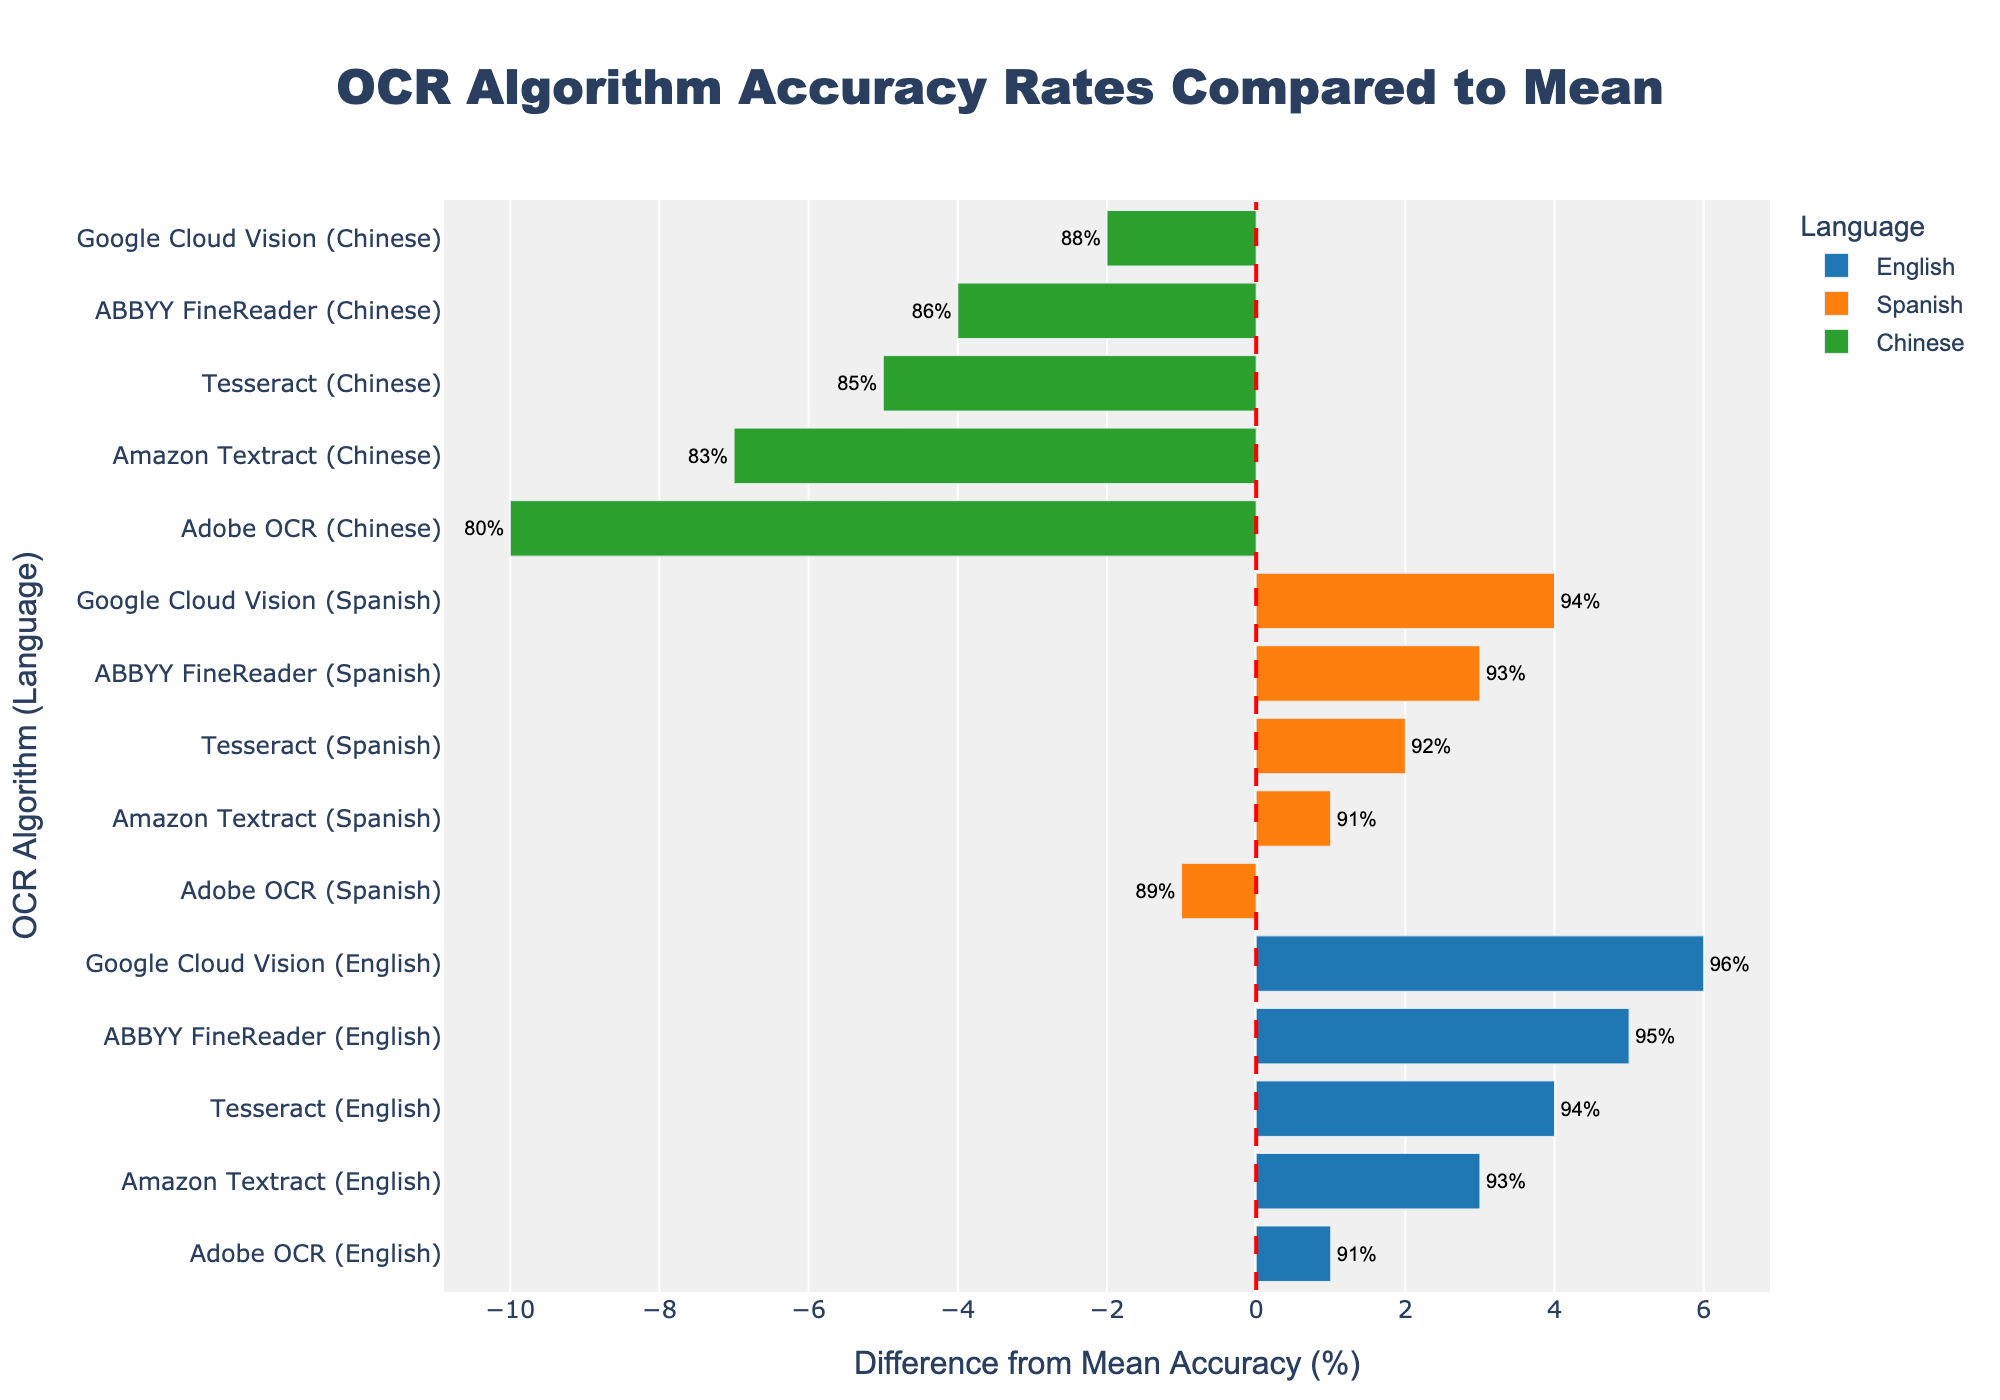Which OCR algorithm has the highest accuracy rate for Chinese? Look at the bars for the Chinese language and visually identify the longest bar. Google Cloud Vision has the highest bar for Chinese, indicating the highest accuracy rate among the OCR algorithms.
Answer: Google Cloud Vision How does the accuracy rate of ABBYY FineReader for Spanish compare to the mean accuracy rate? Locate the bar for ABBYY FineReader (Spanish) and note its position relative to the zero line which represents the mean accuracy. The bar extends positively, indicating it is above the mean.
Answer: Above the mean What is the average accuracy rate for Adobe OCR across all languages? Adobe OCR's accuracy rates are 91% (English), 89% (Spanish), and 80% (Chinese). Calculate the average: (91 + 89 + 80) / 3 = 260 / 3 ≈ 86.67%.
Answer: 86.67% Which language has the most consistent accuracy rates among the different OCR algorithms? Compare the variation in lengths of the bars for each language. The English bars have less variation compared to Spanish and Chinese, indicating higher consistency.
Answer: English What is the difference in accuracy rate between Amazon Textract for English and Chinese? Subtract the accuracy rate of Amazon Textract for Chinese (83%) from its rate for English (93%). The difference is 93 - 83 = 10%.
Answer: 10% Identify any OCR algorithm that performs below the mean for all languages. Look for an algorithm whose bars all fall below the zero line. Adobe OCR's bars for English, Spanish, and Chinese are all positioned below the zero line.
Answer: Adobe OCR Which language's accuracy rates vary the most from the mean accuracy rate? Visually assess the lengths of the bars across languages and note the one with the widest variation. The Chinese bars show the greatest deviation from the mean, both above and below.
Answer: Chinese How many OCR algorithms have a higher accuracy rate than the mean for the English language? Identify the bars for English that extend positively beyond the zero line. Three algorithms (Google Cloud Vision, ABBYY FineReader, and Tesseract) have bars extending positively.
Answer: Three What's the total positive deviation from mean accuracy for Google Cloud Vision across all languages? Sum the positive differences for Google Cloud Vision (English: +2, Spanish: +0, Chinese: +3). +2 + 0 + 3 = +5.
Answer: 5% Which OCR algorithm has the largest negative deviation from the mean accuracy for Spanish? Identify the bar with the largest negative difference for Spanish. Adobe OCR's bar for Spanish has the largest negative deviation.
Answer: Adobe OCR 